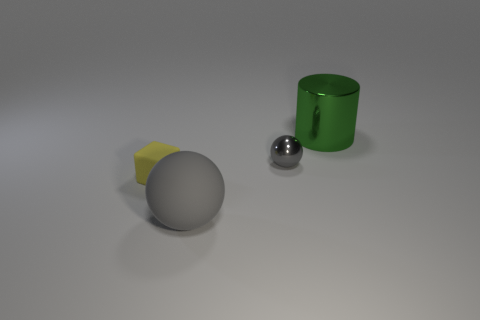Are there any green metal balls that have the same size as the yellow block?
Your response must be concise. No. Are there any large gray matte things that are behind the gray thing behind the tiny block?
Your answer should be very brief. No. How many cylinders are either small brown objects or small gray things?
Offer a terse response. 0. Are there any small shiny objects that have the same shape as the big gray matte object?
Give a very brief answer. Yes. What is the shape of the small shiny thing?
Provide a succinct answer. Sphere. How many objects are either small rubber cubes or large purple metallic cubes?
Make the answer very short. 1. There is a shiny thing behind the tiny gray ball; does it have the same size as the metal object in front of the large green shiny cylinder?
Ensure brevity in your answer.  No. What number of other things are made of the same material as the green thing?
Keep it short and to the point. 1. Are there more gray rubber balls that are to the left of the tiny cube than yellow things that are right of the small metallic thing?
Offer a terse response. No. There is a small object that is in front of the tiny gray sphere; what is its material?
Provide a short and direct response. Rubber. 